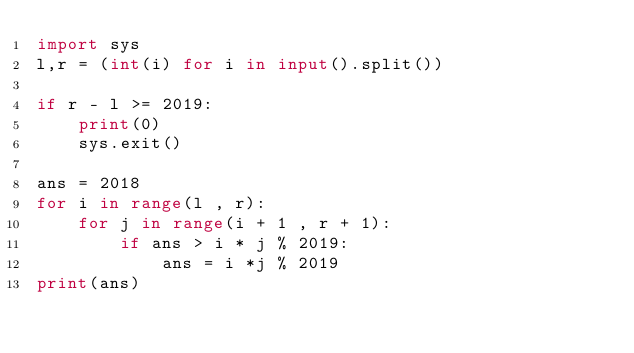<code> <loc_0><loc_0><loc_500><loc_500><_Python_>import sys
l,r = (int(i) for i in input().split())

if r - l >= 2019:
    print(0)
    sys.exit()

ans = 2018
for i in range(l , r):
    for j in range(i + 1 , r + 1):
        if ans > i * j % 2019:
            ans = i *j % 2019
print(ans)

</code> 